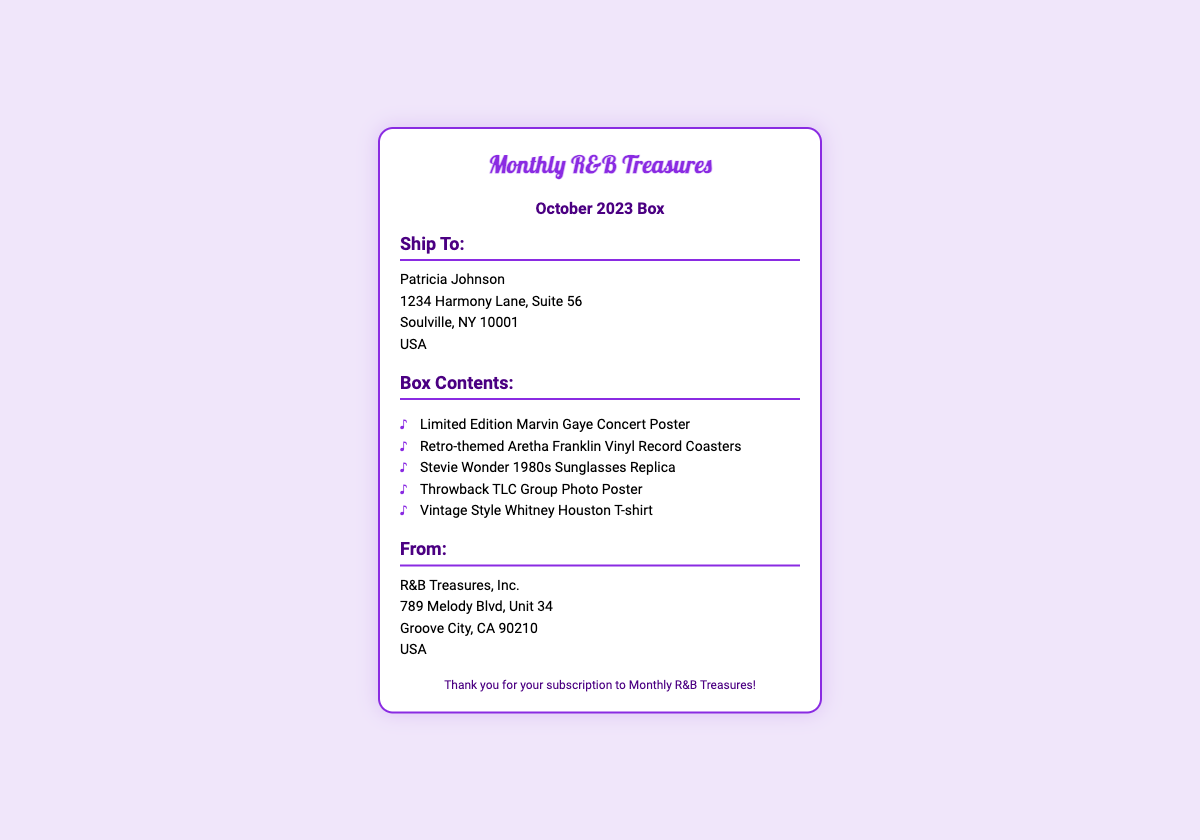What is the name of the recipient? The recipient's name is prominently displayed in the address section, which is Patricia Johnson.
Answer: Patricia Johnson What is the shipping address? The shipping address is found under the "Ship To" heading, including street, city, state, and ZIP code.
Answer: 1234 Harmony Lane, Suite 56, Soulville, NY 10001 What month is the current subscription box for? The subscription details indicate the box is specifically labeled for October 2023.
Answer: October 2023 How many items are listed in the box contents? The number of items can be counted from the unordered list under the "Box Contents" section, which lists five items.
Answer: 5 What is the name of the company sending the box? The sender's information is found in the "From" section, clearly stating the company name.
Answer: R&B Treasures, Inc What type of items are included in this subscription box? The contents itemize various memorabilia, including concert posters and merchandise relating to influential R&B artists.
Answer: R&B memorabilia Where is R&B Treasures, Inc. located? The location of the company can be found in the sender's address section detailing its full address.
Answer: 789 Melody Blvd, Unit 34, Groove City, CA 90210 What is the design theme of the sunglasses? The sunglasses mentioned in the box contents are described using a decade characteristic that is defined as retro.
Answer: 1980s What is the tone of the footer message? The footer expresses gratitude for the subscription, indicating a friendly and appreciative tone.
Answer: Thank you for your subscription to Monthly R&B Treasures! 